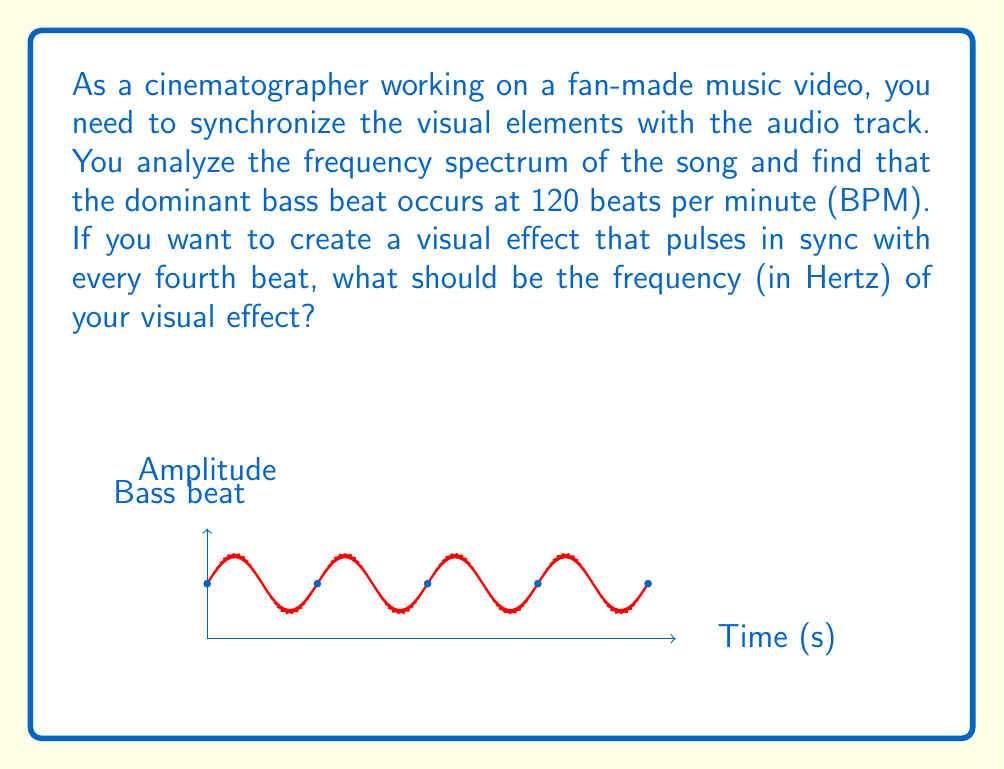Give your solution to this math problem. Let's approach this step-by-step:

1) First, we need to convert the tempo from beats per minute (BPM) to beats per second:
   $$\text{Beats per second} = \frac{120 \text{ BPM}}{60 \text{ seconds/minute}} = 2 \text{ Hz}$$

2) This means the bass beat occurs 2 times per second.

3) However, we want our visual effect to pulse with every fourth beat. This means our visual effect will occur at a frequency that is 1/4 of the bass beat frequency:
   $$\text{Visual effect frequency} = \frac{2 \text{ Hz}}{4} = 0.5 \text{ Hz}$$

4) To verify:
   - The bass beat occurs every 0.5 seconds (1/2 Hz)
   - Our visual effect will occur every 2 seconds (1/0.5 Hz)
   - This indeed corresponds to every fourth beat: 0.5 * 4 = 2 seconds

Therefore, the frequency of the visual effect should be 0.5 Hz to synchronize with every fourth bass beat.
Answer: 0.5 Hz 